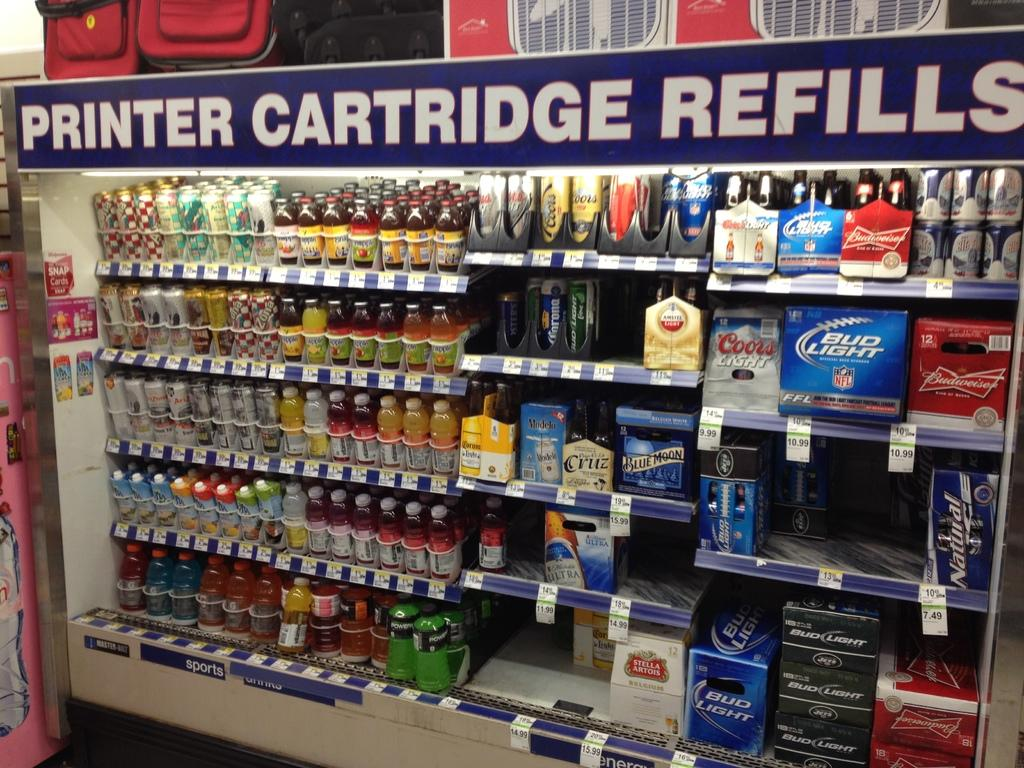<image>
Summarize the visual content of the image. a display of drinks and beer with the sign on top reading Printer Cartridge Refills 